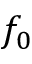<formula> <loc_0><loc_0><loc_500><loc_500>f _ { 0 }</formula> 